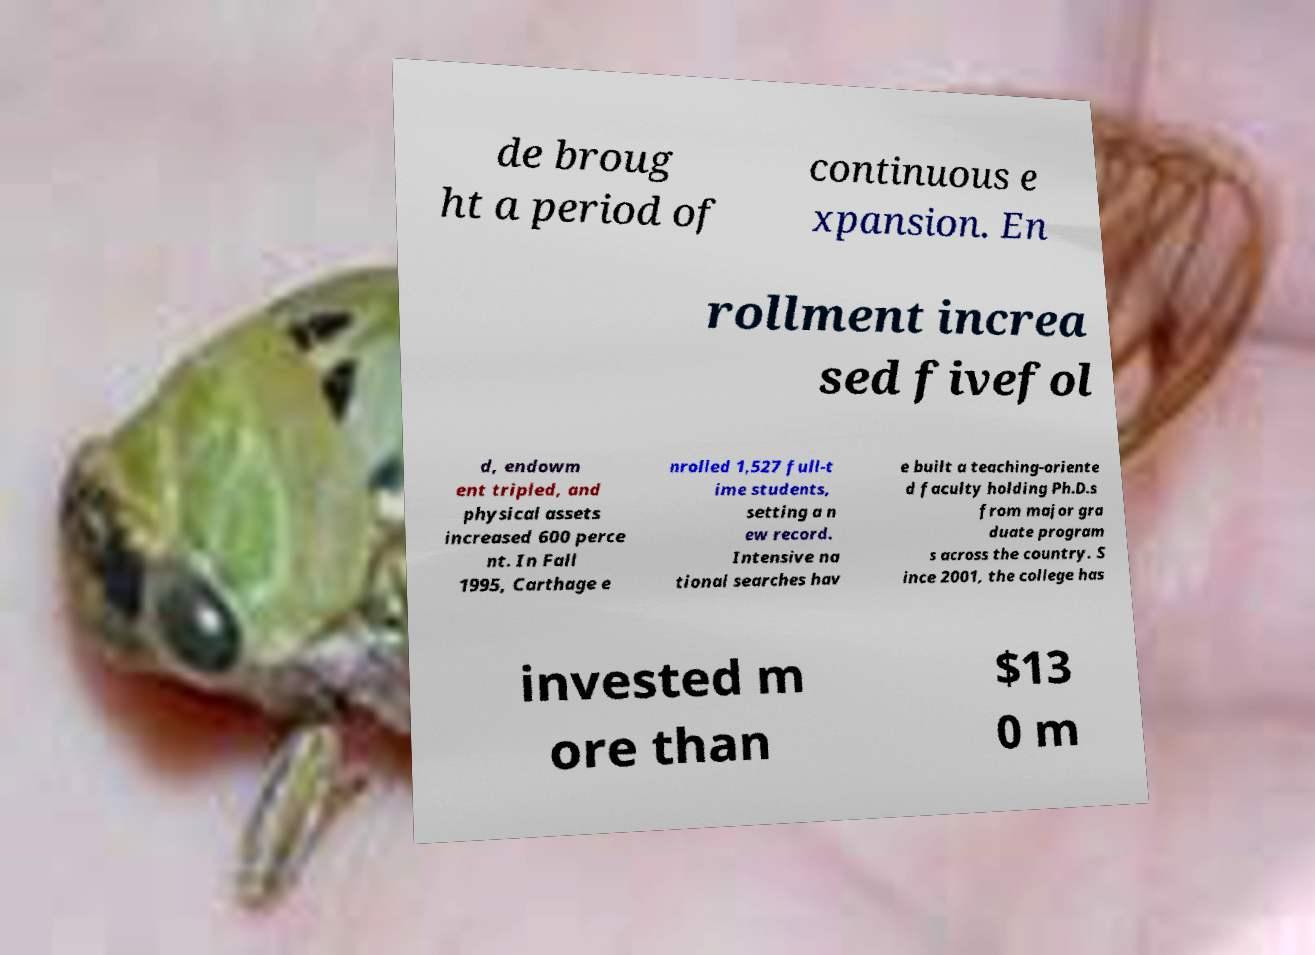I need the written content from this picture converted into text. Can you do that? de broug ht a period of continuous e xpansion. En rollment increa sed fivefol d, endowm ent tripled, and physical assets increased 600 perce nt. In Fall 1995, Carthage e nrolled 1,527 full-t ime students, setting a n ew record. Intensive na tional searches hav e built a teaching-oriente d faculty holding Ph.D.s from major gra duate program s across the country. S ince 2001, the college has invested m ore than $13 0 m 